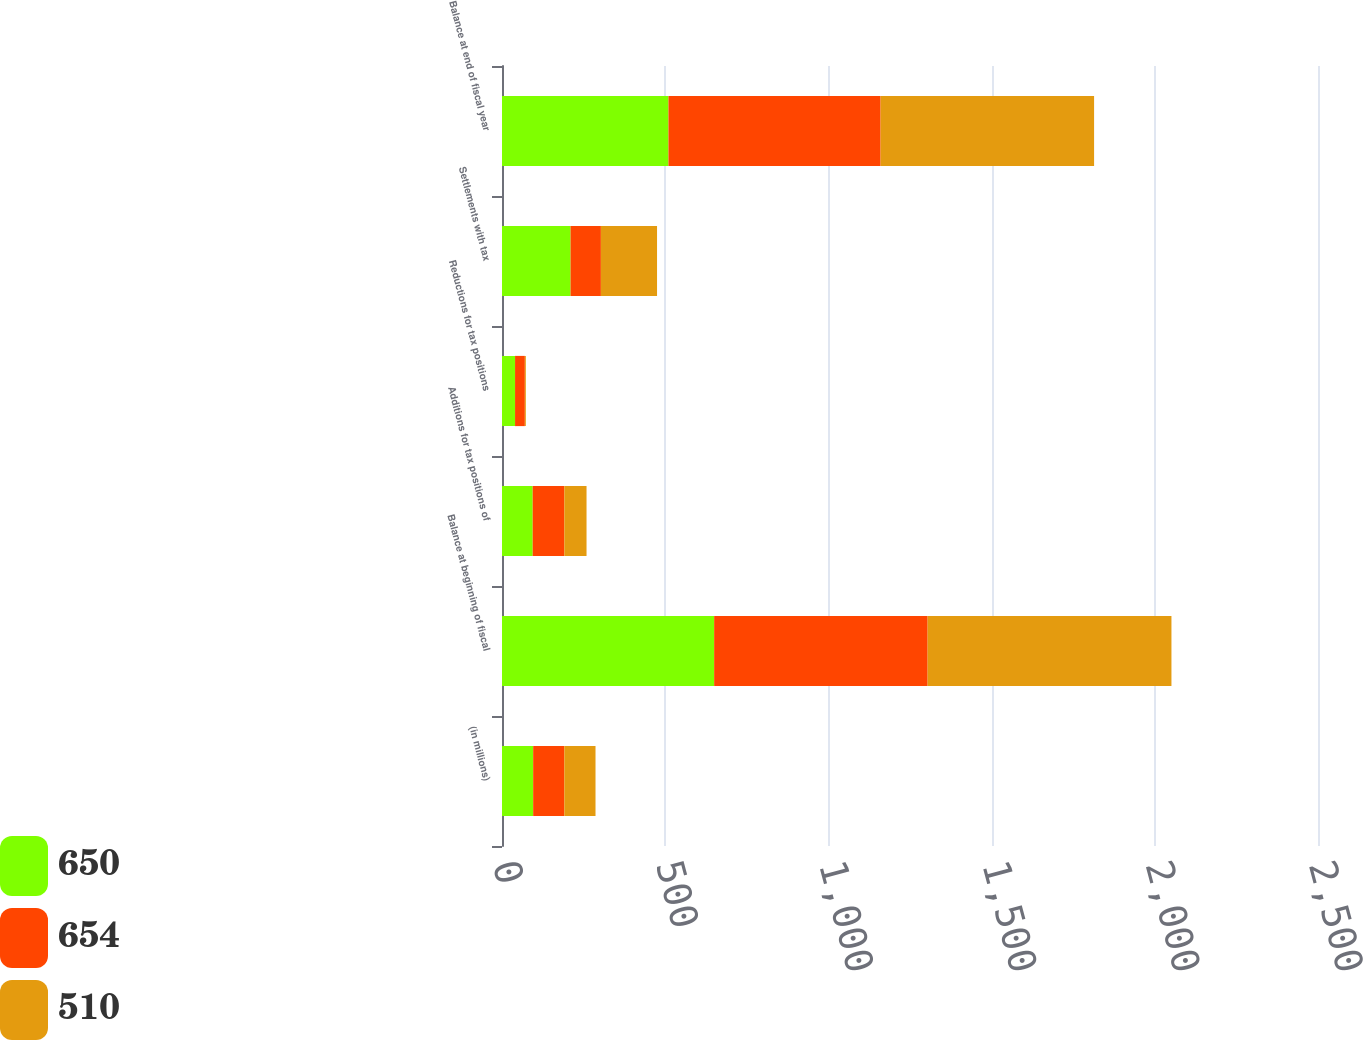Convert chart. <chart><loc_0><loc_0><loc_500><loc_500><stacked_bar_chart><ecel><fcel>(in millions)<fcel>Balance at beginning of fiscal<fcel>Additions for tax positions of<fcel>Reductions for tax positions<fcel>Settlements with tax<fcel>Balance at end of fiscal year<nl><fcel>650<fcel>95.5<fcel>650<fcel>94<fcel>40<fcel>210<fcel>510<nl><fcel>654<fcel>95.5<fcel>654<fcel>97<fcel>30<fcel>93<fcel>650<nl><fcel>510<fcel>95.5<fcel>747<fcel>68<fcel>3<fcel>172<fcel>654<nl></chart> 